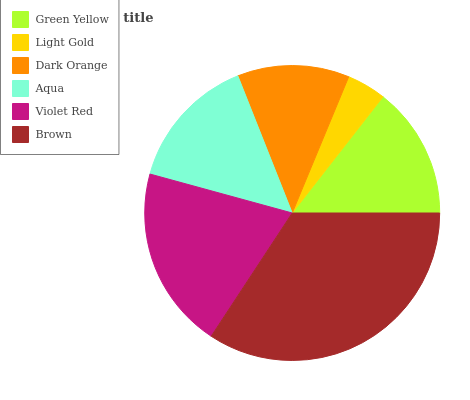Is Light Gold the minimum?
Answer yes or no. Yes. Is Brown the maximum?
Answer yes or no. Yes. Is Dark Orange the minimum?
Answer yes or no. No. Is Dark Orange the maximum?
Answer yes or no. No. Is Dark Orange greater than Light Gold?
Answer yes or no. Yes. Is Light Gold less than Dark Orange?
Answer yes or no. Yes. Is Light Gold greater than Dark Orange?
Answer yes or no. No. Is Dark Orange less than Light Gold?
Answer yes or no. No. Is Aqua the high median?
Answer yes or no. Yes. Is Green Yellow the low median?
Answer yes or no. Yes. Is Brown the high median?
Answer yes or no. No. Is Dark Orange the low median?
Answer yes or no. No. 